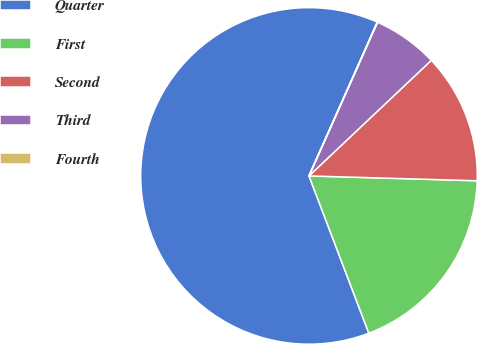<chart> <loc_0><loc_0><loc_500><loc_500><pie_chart><fcel>Quarter<fcel>First<fcel>Second<fcel>Third<fcel>Fourth<nl><fcel>62.43%<fcel>18.75%<fcel>12.51%<fcel>6.27%<fcel>0.03%<nl></chart> 